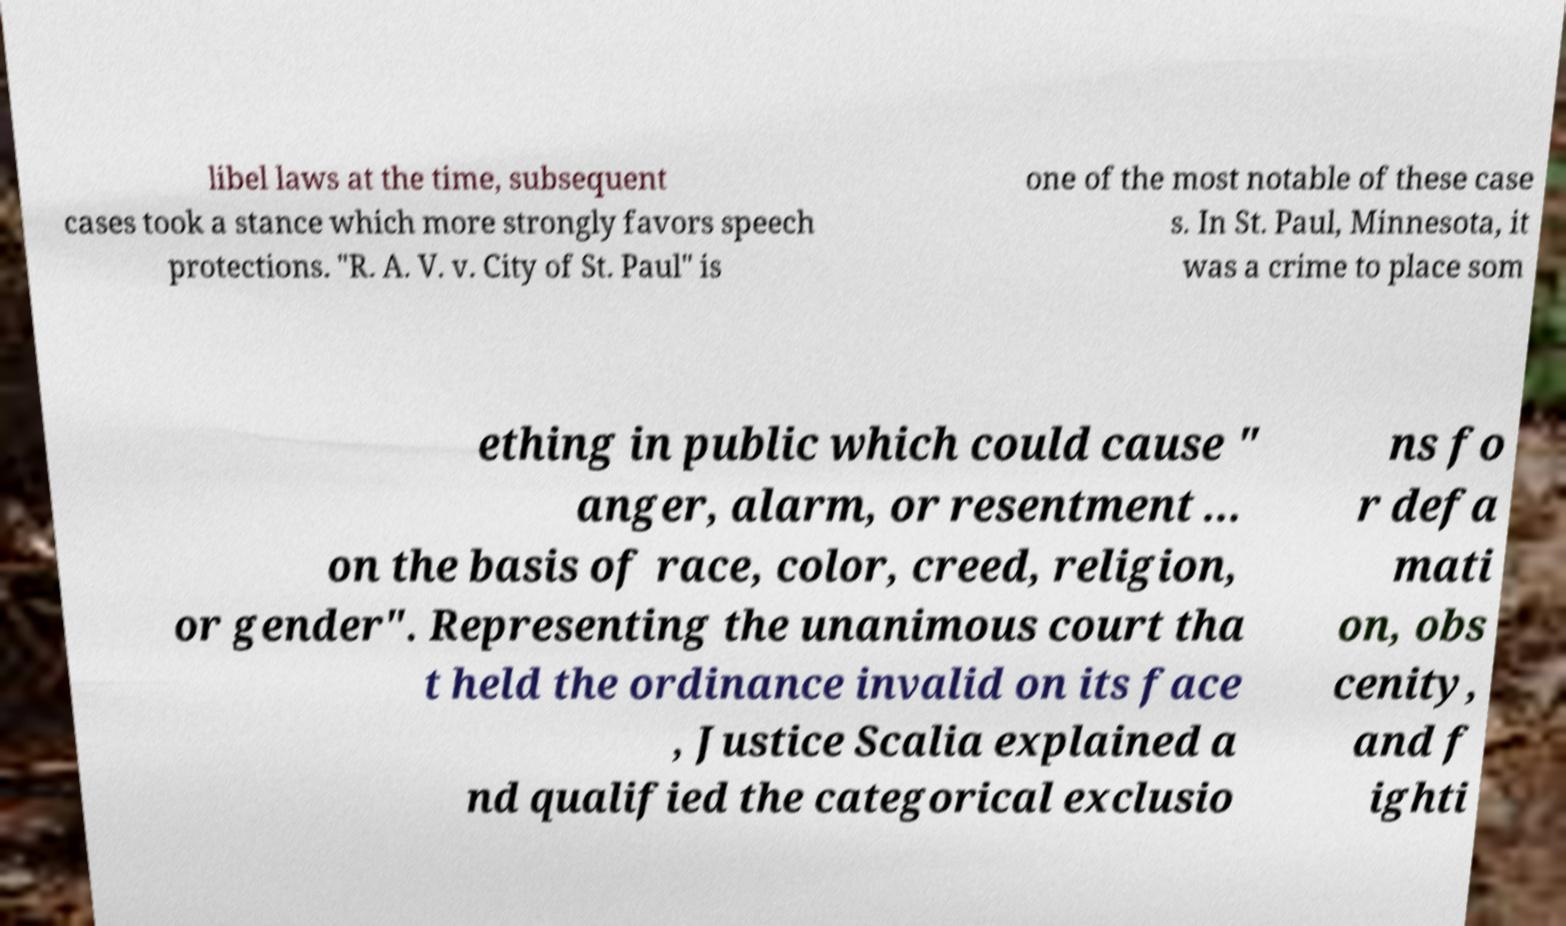Please identify and transcribe the text found in this image. libel laws at the time, subsequent cases took a stance which more strongly favors speech protections. "R. A. V. v. City of St. Paul" is one of the most notable of these case s. In St. Paul, Minnesota, it was a crime to place som ething in public which could cause " anger, alarm, or resentment ... on the basis of race, color, creed, religion, or gender". Representing the unanimous court tha t held the ordinance invalid on its face , Justice Scalia explained a nd qualified the categorical exclusio ns fo r defa mati on, obs cenity, and f ighti 